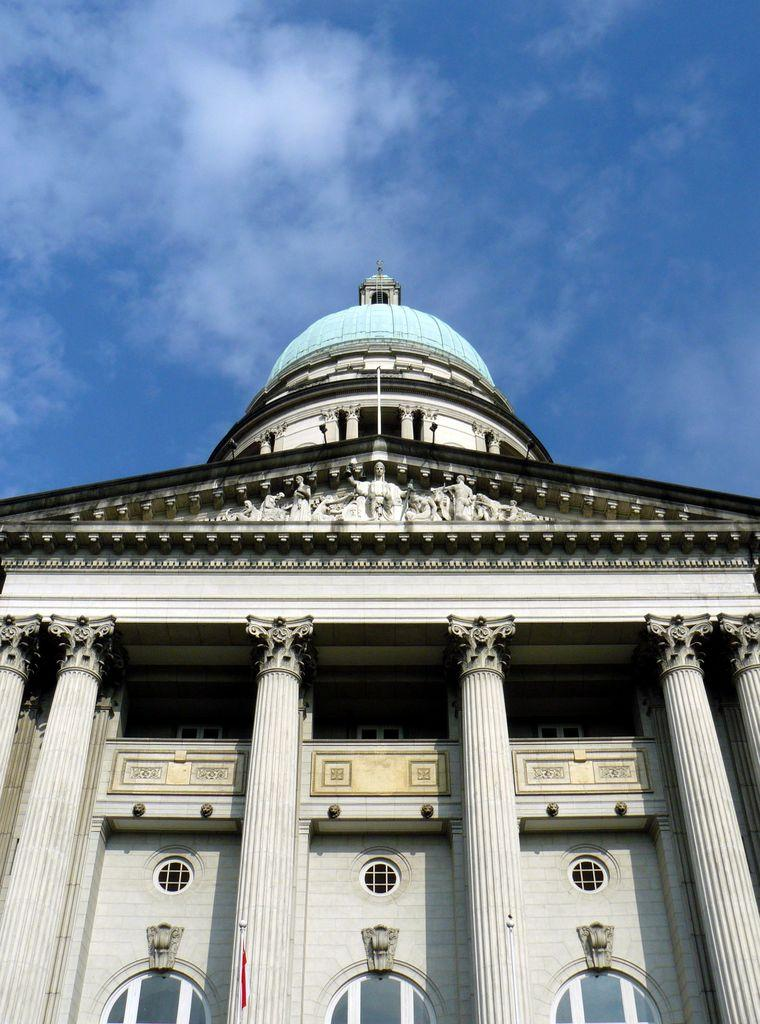What is the color of the building in the image? The building in the image is white-colored. What architectural features can be seen on the building? The building has multiple pillars and sculptures on the top side. What can be seen in the background of the image? There are clouds and the sky visible in the background. What type of observation can be made about the unit in the image? There is no unit mentioned in the image; it features a white-colored building with multiple pillars and sculptures on the top side, along with clouds and the sky visible in the background. 